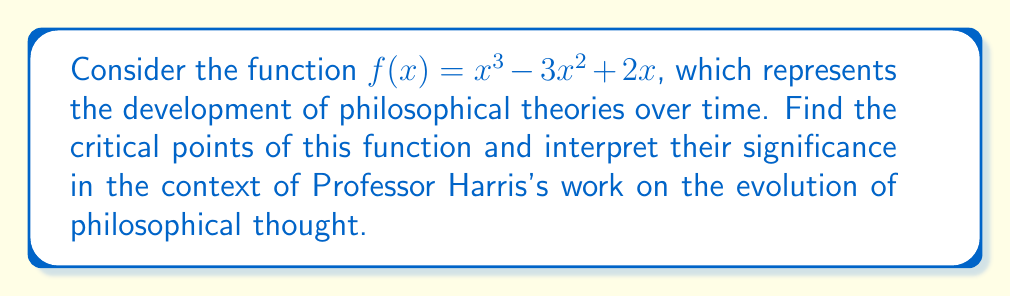Show me your answer to this math problem. To find the critical points, we need to follow these steps:

1. Find the derivative of $f(x)$:
   $$f'(x) = 3x^2 - 6x + 2$$

2. Set the derivative equal to zero and solve for x:
   $$3x^2 - 6x + 2 = 0$$

3. Use the quadratic formula to solve this equation:
   $$x = \frac{-b \pm \sqrt{b^2 - 4ac}}{2a}$$
   where $a=3$, $b=-6$, and $c=2$

4. Plugging in these values:
   $$x = \frac{6 \pm \sqrt{36 - 24}}{6} = \frac{6 \pm \sqrt{12}}{6} = \frac{6 \pm 2\sqrt{3}}{6}$$

5. Simplifying:
   $$x = 1 \pm \frac{\sqrt{3}}{3}$$

6. Therefore, the critical points are:
   $$x_1 = 1 - \frac{\sqrt{3}}{3} \approx 0.423$$
   $$x_2 = 1 + \frac{\sqrt{3}}{3} \approx 1.577$$

Interpretation: In the context of Professor Harris's work, these critical points represent key moments in the development of philosophical theories. The point at $x \approx 0.423$ could signify an early breakthrough in philosophical thought, while the point at $x \approx 1.577$ might represent a later, more mature stage of theoretical development.
Answer: $x_1 = 1 - \frac{\sqrt{3}}{3}, x_2 = 1 + \frac{\sqrt{3}}{3}$ 